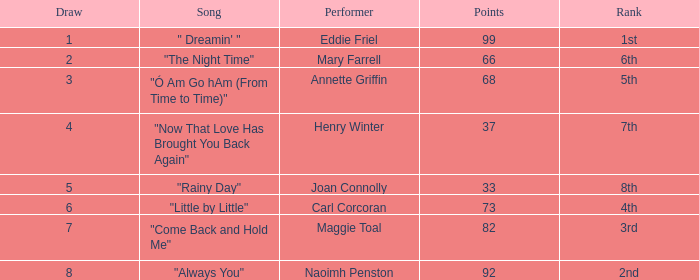Which song has more than 66 points, a draw greater than 3, and is ranked 3rd? "Come Back and Hold Me". Can you parse all the data within this table? {'header': ['Draw', 'Song', 'Performer', 'Points', 'Rank'], 'rows': [['1', '" Dreamin\' "', 'Eddie Friel', '99', '1st'], ['2', '"The Night Time"', 'Mary Farrell', '66', '6th'], ['3', '"Ó Am Go hAm (From Time to Time)"', 'Annette Griffin', '68', '5th'], ['4', '"Now That Love Has Brought You Back Again"', 'Henry Winter', '37', '7th'], ['5', '"Rainy Day"', 'Joan Connolly', '33', '8th'], ['6', '"Little by Little"', 'Carl Corcoran', '73', '4th'], ['7', '"Come Back and Hold Me"', 'Maggie Toal', '82', '3rd'], ['8', '"Always You"', 'Naoimh Penston', '92', '2nd']]} 